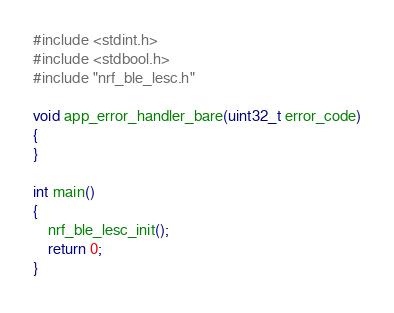<code> <loc_0><loc_0><loc_500><loc_500><_C_>#include <stdint.h>
#include <stdbool.h>
#include "nrf_ble_lesc.h"

void app_error_handler_bare(uint32_t error_code)
{
}

int main()
{
    nrf_ble_lesc_init();
    return 0;
}</code> 